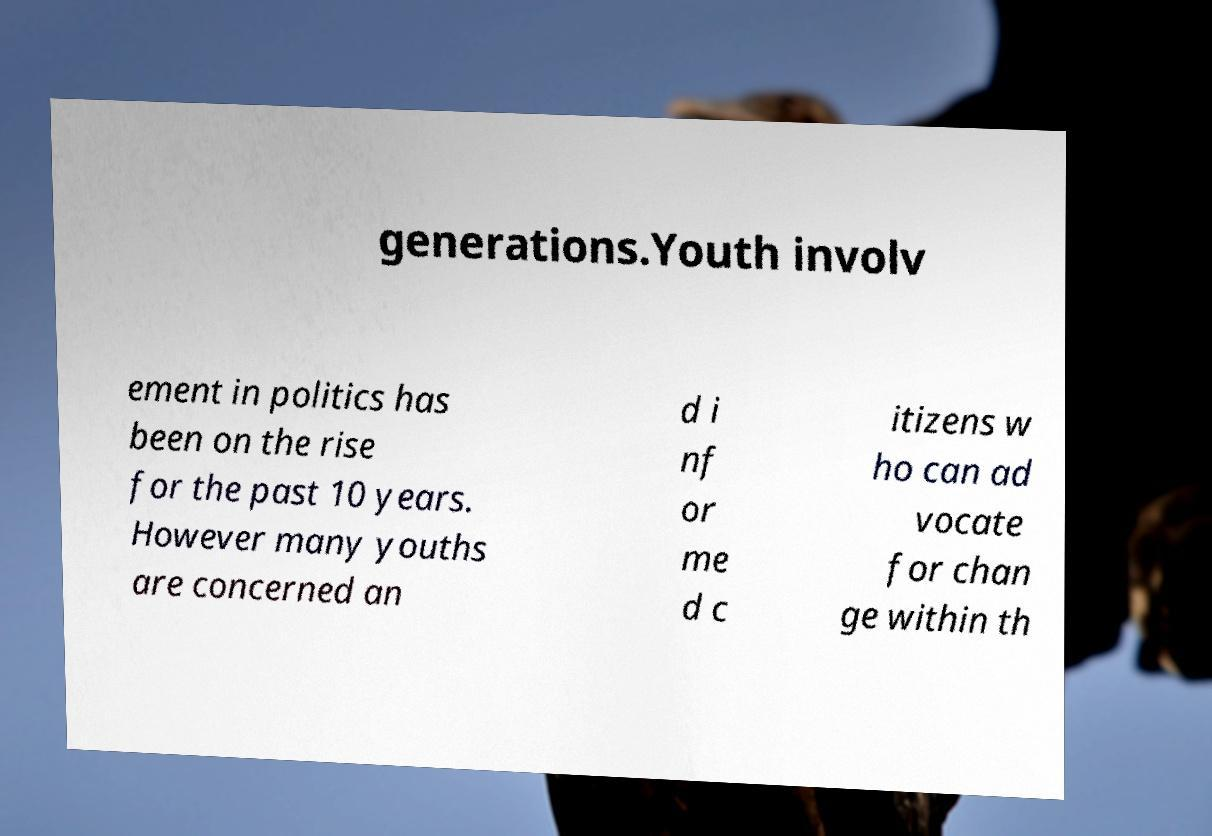Could you extract and type out the text from this image? generations.Youth involv ement in politics has been on the rise for the past 10 years. However many youths are concerned an d i nf or me d c itizens w ho can ad vocate for chan ge within th 